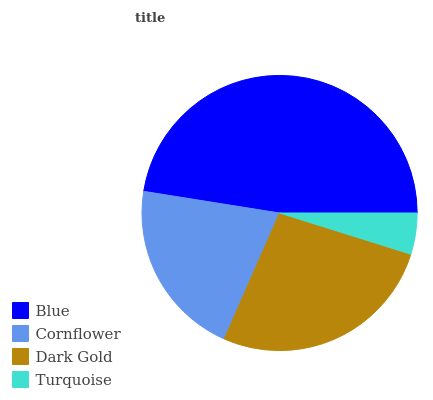Is Turquoise the minimum?
Answer yes or no. Yes. Is Blue the maximum?
Answer yes or no. Yes. Is Cornflower the minimum?
Answer yes or no. No. Is Cornflower the maximum?
Answer yes or no. No. Is Blue greater than Cornflower?
Answer yes or no. Yes. Is Cornflower less than Blue?
Answer yes or no. Yes. Is Cornflower greater than Blue?
Answer yes or no. No. Is Blue less than Cornflower?
Answer yes or no. No. Is Dark Gold the high median?
Answer yes or no. Yes. Is Cornflower the low median?
Answer yes or no. Yes. Is Blue the high median?
Answer yes or no. No. Is Dark Gold the low median?
Answer yes or no. No. 